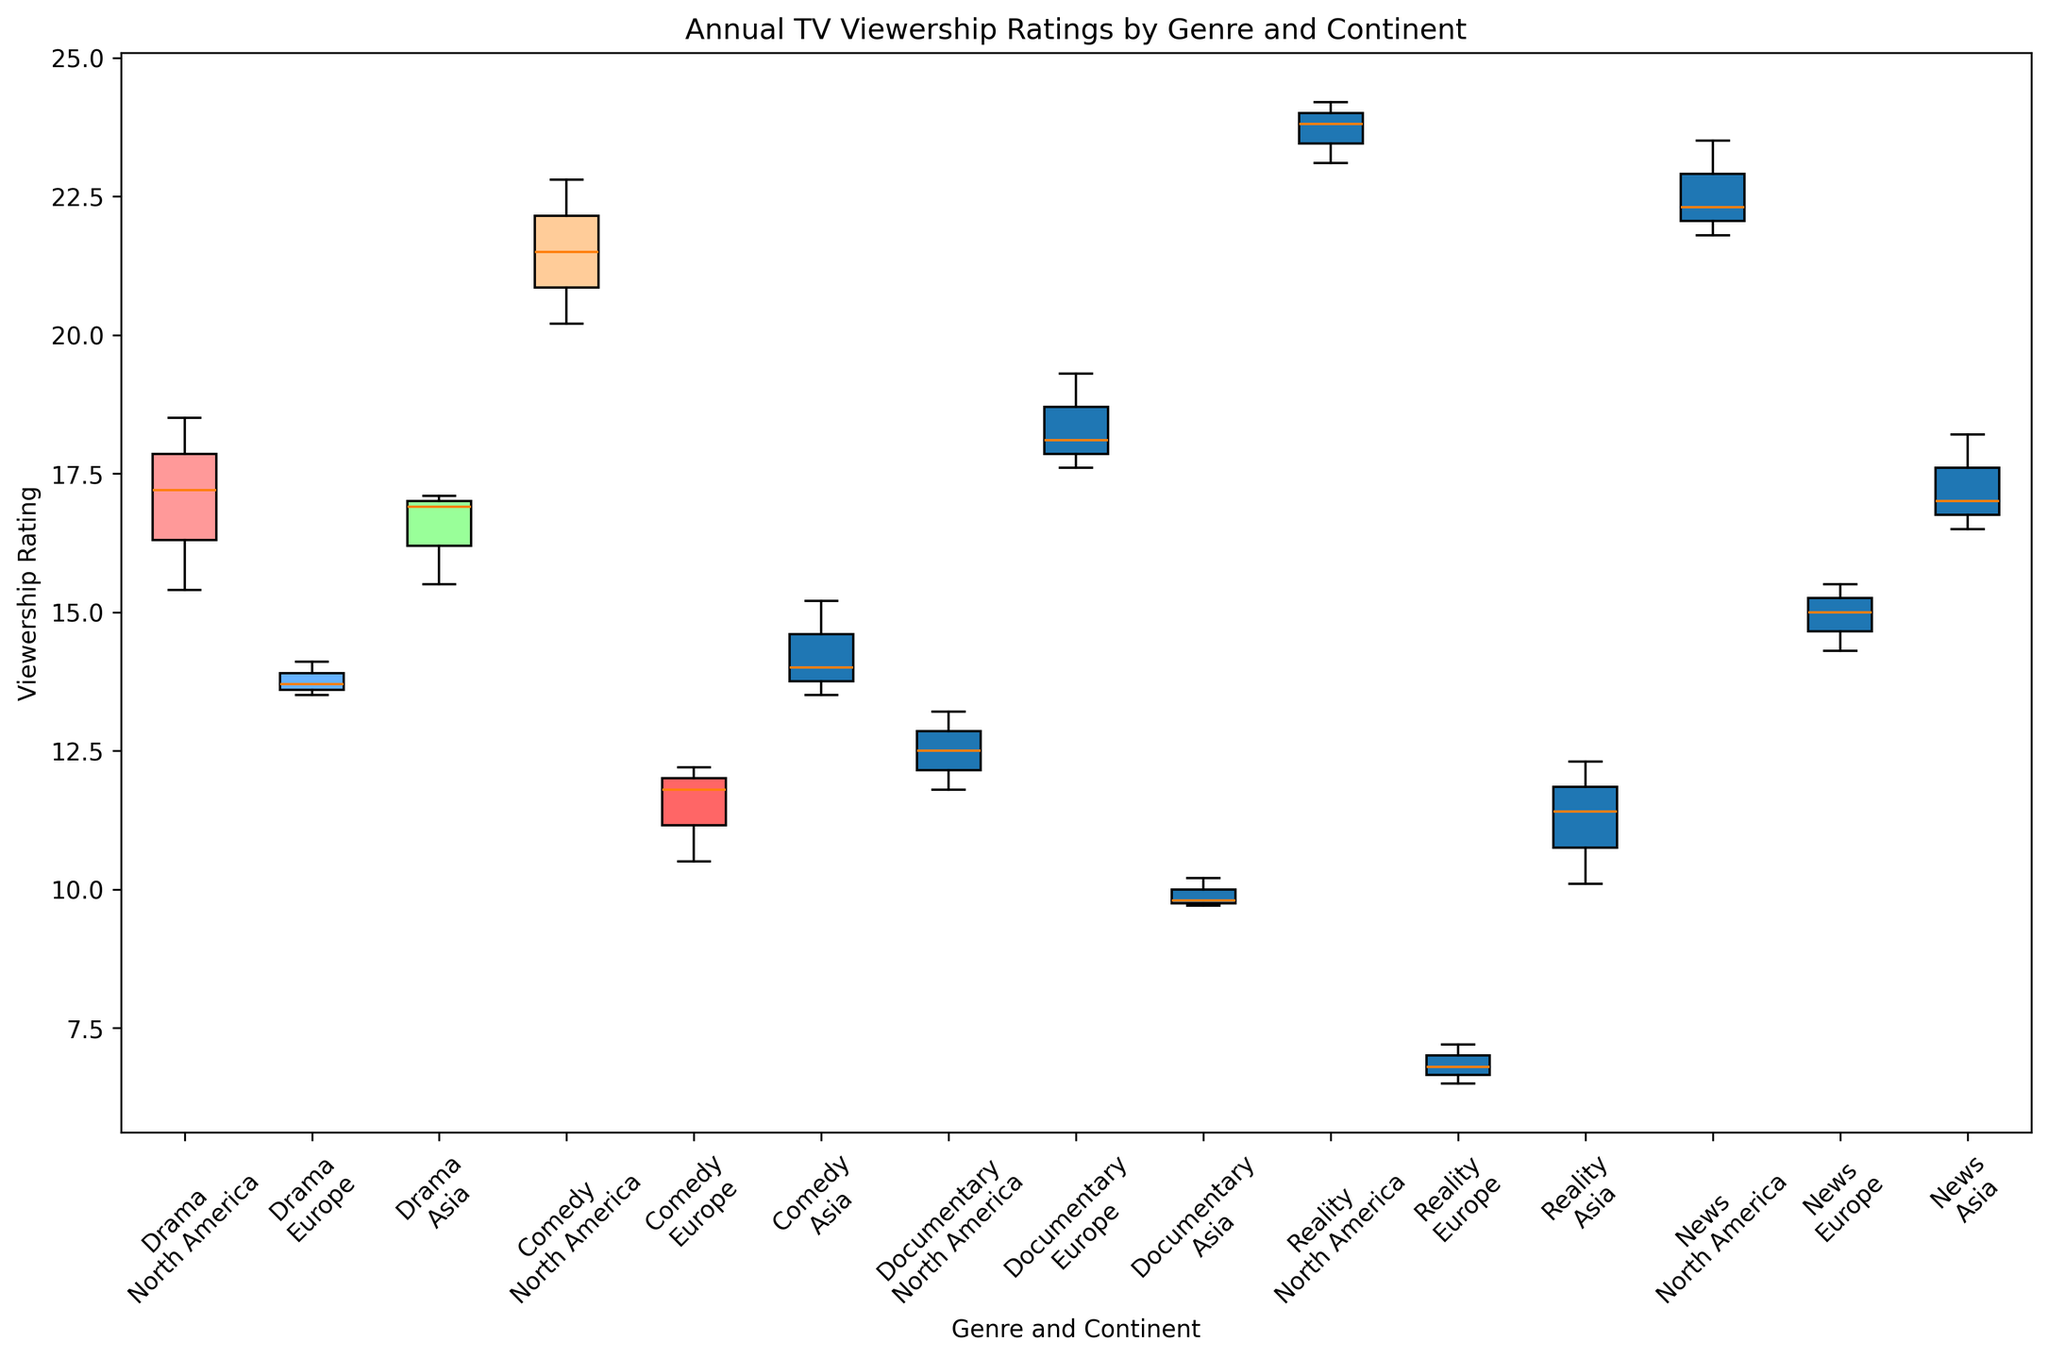Which genre has the highest median viewership in North America? To find the genre with the highest median viewership in North America, observe the middle value of the box for each genre in North America. The "Reality" genre has the highest median.
Answer: Reality Which genre in Asia has the lowest overall viewership range (i.e., the difference between the highest and lowest values)? Look at the span from the lowest to the highest point in the box plot for each genre in Asia. The "Documentary" genre has the smallest range in Asia.
Answer: Documentary Which has a higher median viewership, Drama in North America or News in Europe? Compare the middle value of the box for Drama in North America and News in Europe. Drama in North America has a higher median than News in Europe.
Answer: Drama in North America What is the interquartile range (IQR) for Comedy in Europe? The IQR is the difference between the first quartile (Q1) and the third quartile (Q3). Measure the span of the box for Comedy in Europe.
Answer: 1.7 Which genre and continent combination has the greatest variation in viewership? Variation can be seen as the length between the minimum and maximum whiskers. Reality in North America has the largest variation.
Answer: Reality in North America Is the median viewership of Documentaries higher in Europe or Asia? Compare the median line in the box for Documentaries in Europe and Asia. Europe has a higher median viewership for Documentaries than Asia.
Answer: Europe Are the viewership ratings for Comedy in North America generally higher or lower than in Asia? Observe the positions of the boxes and their whiskers for Comedy in North America and Asia. Comedy in North America generally has higher ratings than in Asia.
Answer: Higher Between Asia and Europe, which continent shows a higher median viewership for Drama? Compare the median lines within the boxes for Drama in Asia and Europe. Asia has a higher median viewership for Drama than Europe.
Answer: Asia What is the approximate range of viewership for News in Asia? The range can be determined by looking at the lowest and highest points (whiskers) for News in Asia. The range is about 16.5 to 18.2.
Answer: 1.7 Do Reality TV shows in Europe have a higher or lower median viewership compared to Documentaries in North America? Compare the median line of Reality TV shows in Europe with the median line of Documentaries in North America. Reality TV shows in Europe have a lower median viewership than Documentaries in North America.
Answer: Lower 